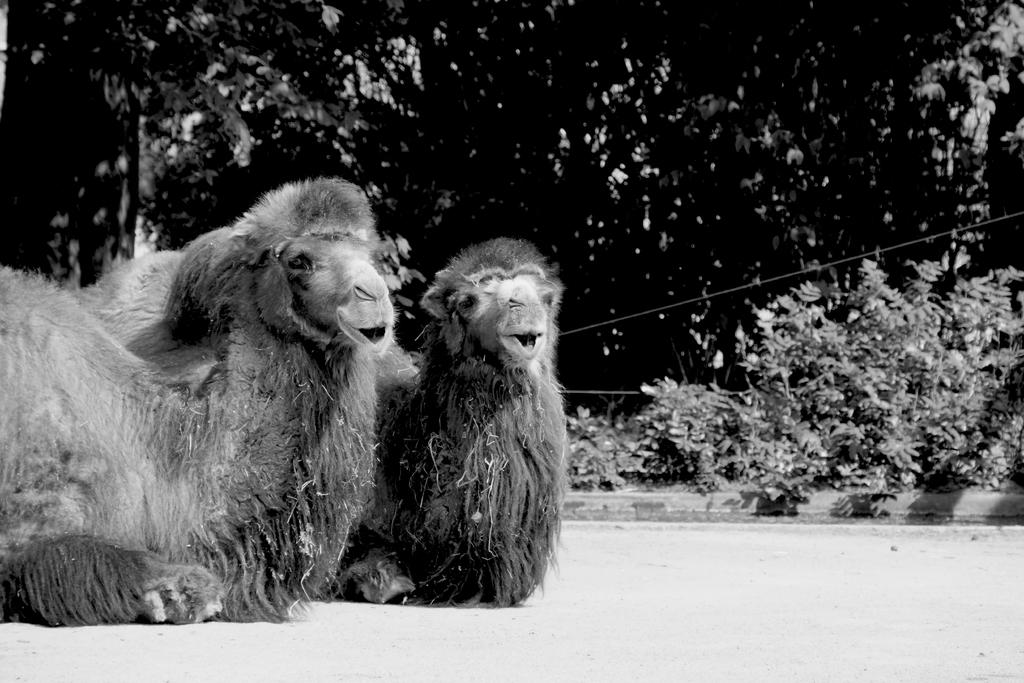What type of animals can be seen on the ground in the image? The image does not specify the type of animals present on the ground. What can be seen in the background of the image? There are trees and plants in the background of the image. What type of behavior can be observed in the animals in the image? The image does not provide any information about the behavior of the animals. How many apples are visible in the image? There are no apples present in the image. Is there a rifle visible in the image? There is no rifle present in the image. 